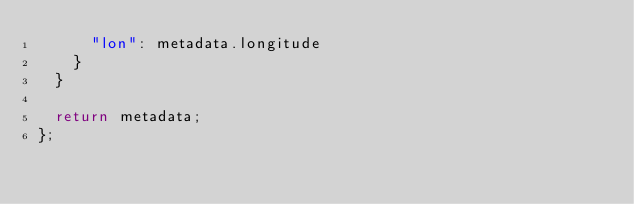Convert code to text. <code><loc_0><loc_0><loc_500><loc_500><_JavaScript_>      "lon": metadata.longitude
    }
  }

  return metadata;
};
</code> 